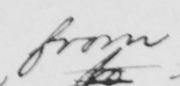What text is written in this handwritten line? from 